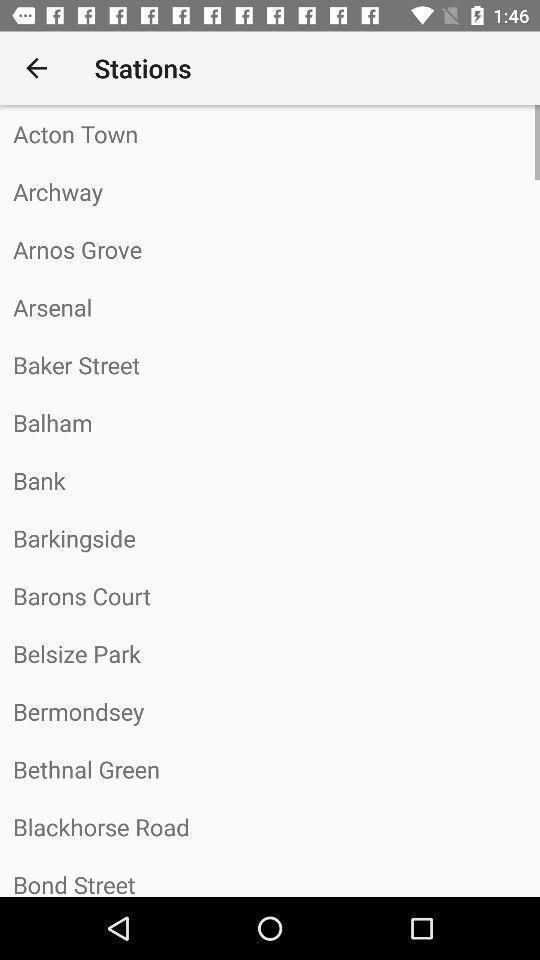Give me a narrative description of this picture. Page displays list of stations in app. 